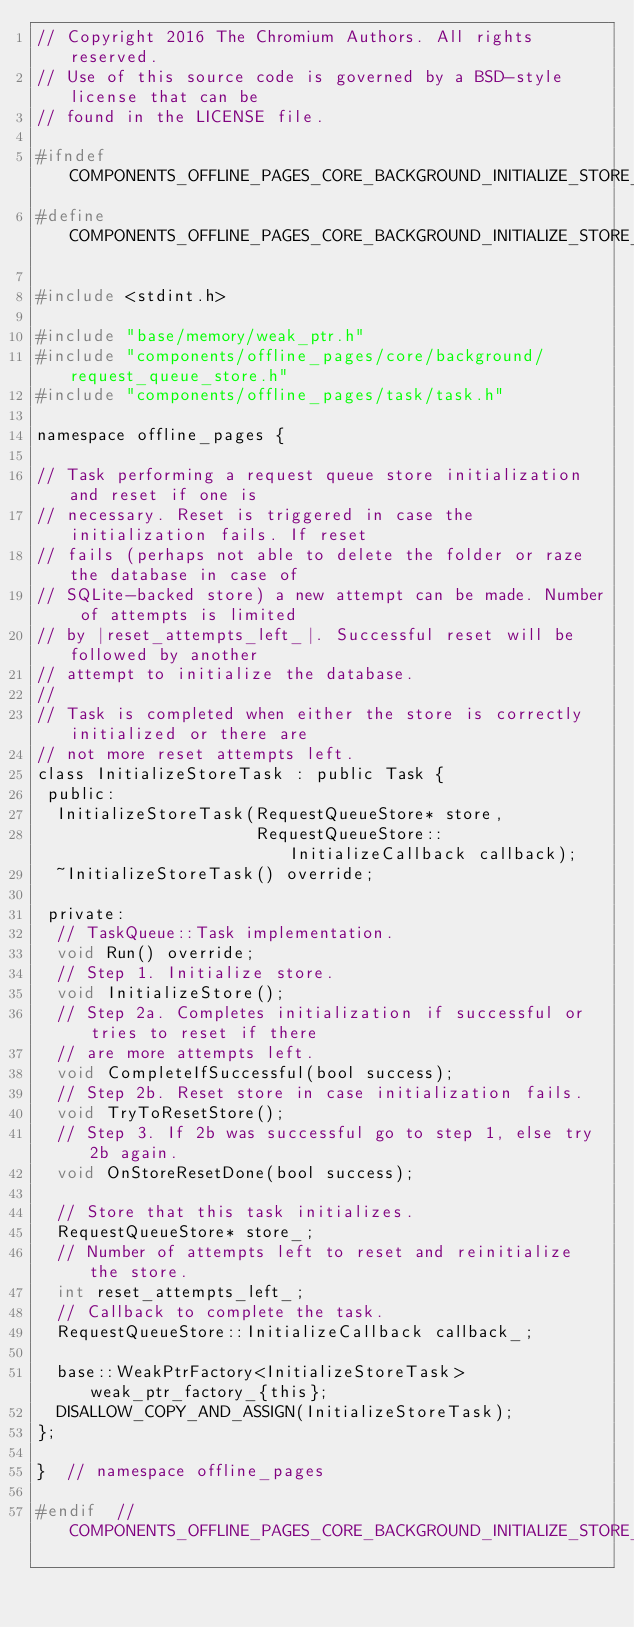Convert code to text. <code><loc_0><loc_0><loc_500><loc_500><_C_>// Copyright 2016 The Chromium Authors. All rights reserved.
// Use of this source code is governed by a BSD-style license that can be
// found in the LICENSE file.

#ifndef COMPONENTS_OFFLINE_PAGES_CORE_BACKGROUND_INITIALIZE_STORE_TASK_H_
#define COMPONENTS_OFFLINE_PAGES_CORE_BACKGROUND_INITIALIZE_STORE_TASK_H_

#include <stdint.h>

#include "base/memory/weak_ptr.h"
#include "components/offline_pages/core/background/request_queue_store.h"
#include "components/offline_pages/task/task.h"

namespace offline_pages {

// Task performing a request queue store initialization and reset if one is
// necessary. Reset is triggered in case the initialization fails. If reset
// fails (perhaps not able to delete the folder or raze the database in case of
// SQLite-backed store) a new attempt can be made. Number of attempts is limited
// by |reset_attempts_left_|. Successful reset will be followed by another
// attempt to initialize the database.
//
// Task is completed when either the store is correctly initialized or there are
// not more reset attempts left.
class InitializeStoreTask : public Task {
 public:
  InitializeStoreTask(RequestQueueStore* store,
                      RequestQueueStore::InitializeCallback callback);
  ~InitializeStoreTask() override;

 private:
  // TaskQueue::Task implementation.
  void Run() override;
  // Step 1. Initialize store.
  void InitializeStore();
  // Step 2a. Completes initialization if successful or tries to reset if there
  // are more attempts left.
  void CompleteIfSuccessful(bool success);
  // Step 2b. Reset store in case initialization fails.
  void TryToResetStore();
  // Step 3. If 2b was successful go to step 1, else try 2b again.
  void OnStoreResetDone(bool success);

  // Store that this task initializes.
  RequestQueueStore* store_;
  // Number of attempts left to reset and reinitialize the store.
  int reset_attempts_left_;
  // Callback to complete the task.
  RequestQueueStore::InitializeCallback callback_;

  base::WeakPtrFactory<InitializeStoreTask> weak_ptr_factory_{this};
  DISALLOW_COPY_AND_ASSIGN(InitializeStoreTask);
};

}  // namespace offline_pages

#endif  // COMPONENTS_OFFLINE_PAGES_CORE_BACKGROUND_INITIALIZE_STORE_TASK_H_
</code> 